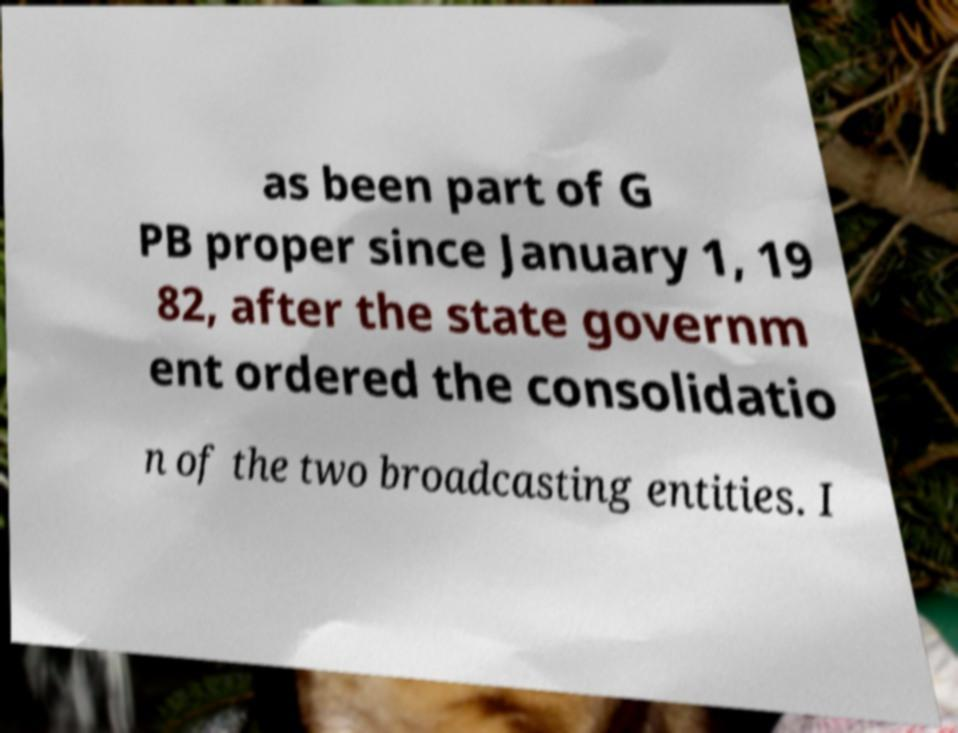Can you read and provide the text displayed in the image?This photo seems to have some interesting text. Can you extract and type it out for me? as been part of G PB proper since January 1, 19 82, after the state governm ent ordered the consolidatio n of the two broadcasting entities. I 